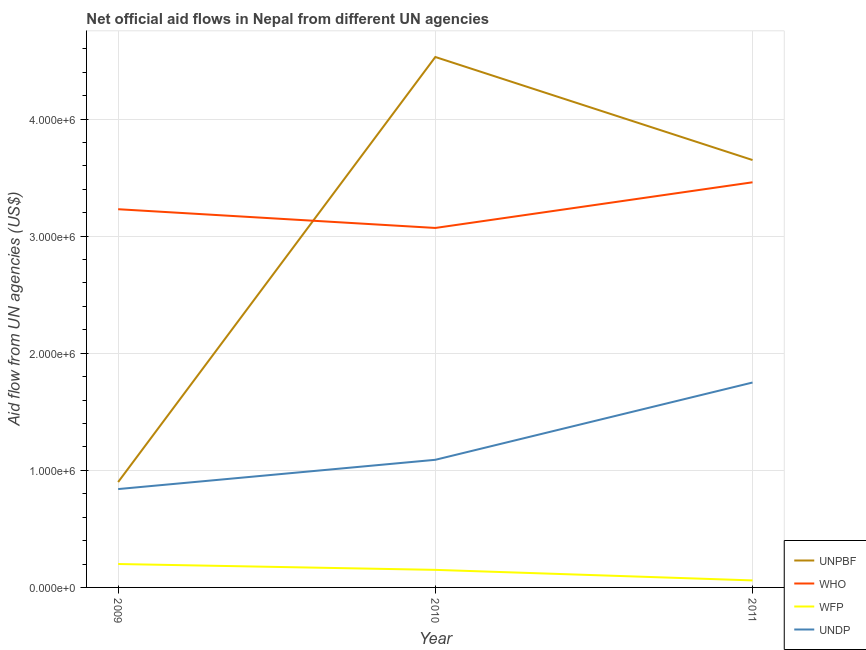How many different coloured lines are there?
Your answer should be compact. 4. What is the amount of aid given by undp in 2009?
Offer a terse response. 8.40e+05. Across all years, what is the maximum amount of aid given by undp?
Give a very brief answer. 1.75e+06. Across all years, what is the minimum amount of aid given by wfp?
Keep it short and to the point. 6.00e+04. In which year was the amount of aid given by wfp minimum?
Your answer should be very brief. 2011. What is the total amount of aid given by wfp in the graph?
Make the answer very short. 4.10e+05. What is the difference between the amount of aid given by who in 2009 and that in 2011?
Offer a very short reply. -2.30e+05. What is the difference between the amount of aid given by unpbf in 2011 and the amount of aid given by wfp in 2009?
Keep it short and to the point. 3.45e+06. What is the average amount of aid given by unpbf per year?
Give a very brief answer. 3.03e+06. In the year 2011, what is the difference between the amount of aid given by wfp and amount of aid given by unpbf?
Offer a very short reply. -3.59e+06. In how many years, is the amount of aid given by unpbf greater than 3000000 US$?
Your answer should be very brief. 2. What is the ratio of the amount of aid given by wfp in 2009 to that in 2010?
Offer a terse response. 1.33. What is the difference between the highest and the lowest amount of aid given by undp?
Keep it short and to the point. 9.10e+05. In how many years, is the amount of aid given by wfp greater than the average amount of aid given by wfp taken over all years?
Your answer should be very brief. 2. Is the sum of the amount of aid given by unpbf in 2010 and 2011 greater than the maximum amount of aid given by wfp across all years?
Provide a short and direct response. Yes. Is it the case that in every year, the sum of the amount of aid given by unpbf and amount of aid given by who is greater than the amount of aid given by wfp?
Your response must be concise. Yes. Does the amount of aid given by unpbf monotonically increase over the years?
Provide a short and direct response. No. Is the amount of aid given by who strictly greater than the amount of aid given by undp over the years?
Ensure brevity in your answer.  Yes. Is the amount of aid given by undp strictly less than the amount of aid given by wfp over the years?
Offer a terse response. No. Are the values on the major ticks of Y-axis written in scientific E-notation?
Your answer should be very brief. Yes. Does the graph contain any zero values?
Your answer should be compact. No. Where does the legend appear in the graph?
Give a very brief answer. Bottom right. How many legend labels are there?
Make the answer very short. 4. What is the title of the graph?
Provide a short and direct response. Net official aid flows in Nepal from different UN agencies. Does "Taxes on revenue" appear as one of the legend labels in the graph?
Your response must be concise. No. What is the label or title of the Y-axis?
Keep it short and to the point. Aid flow from UN agencies (US$). What is the Aid flow from UN agencies (US$) in UNPBF in 2009?
Your answer should be very brief. 9.00e+05. What is the Aid flow from UN agencies (US$) in WHO in 2009?
Your answer should be very brief. 3.23e+06. What is the Aid flow from UN agencies (US$) of WFP in 2009?
Make the answer very short. 2.00e+05. What is the Aid flow from UN agencies (US$) in UNDP in 2009?
Your response must be concise. 8.40e+05. What is the Aid flow from UN agencies (US$) of UNPBF in 2010?
Your answer should be compact. 4.53e+06. What is the Aid flow from UN agencies (US$) of WHO in 2010?
Your answer should be very brief. 3.07e+06. What is the Aid flow from UN agencies (US$) of WFP in 2010?
Give a very brief answer. 1.50e+05. What is the Aid flow from UN agencies (US$) in UNDP in 2010?
Your answer should be very brief. 1.09e+06. What is the Aid flow from UN agencies (US$) of UNPBF in 2011?
Provide a succinct answer. 3.65e+06. What is the Aid flow from UN agencies (US$) in WHO in 2011?
Give a very brief answer. 3.46e+06. What is the Aid flow from UN agencies (US$) of UNDP in 2011?
Provide a succinct answer. 1.75e+06. Across all years, what is the maximum Aid flow from UN agencies (US$) of UNPBF?
Ensure brevity in your answer.  4.53e+06. Across all years, what is the maximum Aid flow from UN agencies (US$) in WHO?
Make the answer very short. 3.46e+06. Across all years, what is the maximum Aid flow from UN agencies (US$) of WFP?
Make the answer very short. 2.00e+05. Across all years, what is the maximum Aid flow from UN agencies (US$) of UNDP?
Keep it short and to the point. 1.75e+06. Across all years, what is the minimum Aid flow from UN agencies (US$) of WHO?
Your answer should be very brief. 3.07e+06. Across all years, what is the minimum Aid flow from UN agencies (US$) of WFP?
Your answer should be very brief. 6.00e+04. Across all years, what is the minimum Aid flow from UN agencies (US$) in UNDP?
Keep it short and to the point. 8.40e+05. What is the total Aid flow from UN agencies (US$) of UNPBF in the graph?
Keep it short and to the point. 9.08e+06. What is the total Aid flow from UN agencies (US$) in WHO in the graph?
Provide a succinct answer. 9.76e+06. What is the total Aid flow from UN agencies (US$) of UNDP in the graph?
Your answer should be very brief. 3.68e+06. What is the difference between the Aid flow from UN agencies (US$) of UNPBF in 2009 and that in 2010?
Give a very brief answer. -3.63e+06. What is the difference between the Aid flow from UN agencies (US$) in WHO in 2009 and that in 2010?
Your response must be concise. 1.60e+05. What is the difference between the Aid flow from UN agencies (US$) in WFP in 2009 and that in 2010?
Your answer should be very brief. 5.00e+04. What is the difference between the Aid flow from UN agencies (US$) of UNPBF in 2009 and that in 2011?
Give a very brief answer. -2.75e+06. What is the difference between the Aid flow from UN agencies (US$) of WHO in 2009 and that in 2011?
Ensure brevity in your answer.  -2.30e+05. What is the difference between the Aid flow from UN agencies (US$) of UNDP in 2009 and that in 2011?
Your answer should be very brief. -9.10e+05. What is the difference between the Aid flow from UN agencies (US$) in UNPBF in 2010 and that in 2011?
Your answer should be compact. 8.80e+05. What is the difference between the Aid flow from UN agencies (US$) of WHO in 2010 and that in 2011?
Provide a short and direct response. -3.90e+05. What is the difference between the Aid flow from UN agencies (US$) of WFP in 2010 and that in 2011?
Your response must be concise. 9.00e+04. What is the difference between the Aid flow from UN agencies (US$) in UNDP in 2010 and that in 2011?
Give a very brief answer. -6.60e+05. What is the difference between the Aid flow from UN agencies (US$) of UNPBF in 2009 and the Aid flow from UN agencies (US$) of WHO in 2010?
Give a very brief answer. -2.17e+06. What is the difference between the Aid flow from UN agencies (US$) of UNPBF in 2009 and the Aid flow from UN agencies (US$) of WFP in 2010?
Give a very brief answer. 7.50e+05. What is the difference between the Aid flow from UN agencies (US$) in WHO in 2009 and the Aid flow from UN agencies (US$) in WFP in 2010?
Make the answer very short. 3.08e+06. What is the difference between the Aid flow from UN agencies (US$) of WHO in 2009 and the Aid flow from UN agencies (US$) of UNDP in 2010?
Give a very brief answer. 2.14e+06. What is the difference between the Aid flow from UN agencies (US$) in WFP in 2009 and the Aid flow from UN agencies (US$) in UNDP in 2010?
Give a very brief answer. -8.90e+05. What is the difference between the Aid flow from UN agencies (US$) of UNPBF in 2009 and the Aid flow from UN agencies (US$) of WHO in 2011?
Give a very brief answer. -2.56e+06. What is the difference between the Aid flow from UN agencies (US$) in UNPBF in 2009 and the Aid flow from UN agencies (US$) in WFP in 2011?
Give a very brief answer. 8.40e+05. What is the difference between the Aid flow from UN agencies (US$) in UNPBF in 2009 and the Aid flow from UN agencies (US$) in UNDP in 2011?
Your answer should be compact. -8.50e+05. What is the difference between the Aid flow from UN agencies (US$) in WHO in 2009 and the Aid flow from UN agencies (US$) in WFP in 2011?
Provide a succinct answer. 3.17e+06. What is the difference between the Aid flow from UN agencies (US$) in WHO in 2009 and the Aid flow from UN agencies (US$) in UNDP in 2011?
Ensure brevity in your answer.  1.48e+06. What is the difference between the Aid flow from UN agencies (US$) of WFP in 2009 and the Aid flow from UN agencies (US$) of UNDP in 2011?
Provide a succinct answer. -1.55e+06. What is the difference between the Aid flow from UN agencies (US$) in UNPBF in 2010 and the Aid flow from UN agencies (US$) in WHO in 2011?
Make the answer very short. 1.07e+06. What is the difference between the Aid flow from UN agencies (US$) in UNPBF in 2010 and the Aid flow from UN agencies (US$) in WFP in 2011?
Your response must be concise. 4.47e+06. What is the difference between the Aid flow from UN agencies (US$) in UNPBF in 2010 and the Aid flow from UN agencies (US$) in UNDP in 2011?
Make the answer very short. 2.78e+06. What is the difference between the Aid flow from UN agencies (US$) of WHO in 2010 and the Aid flow from UN agencies (US$) of WFP in 2011?
Your answer should be very brief. 3.01e+06. What is the difference between the Aid flow from UN agencies (US$) of WHO in 2010 and the Aid flow from UN agencies (US$) of UNDP in 2011?
Your response must be concise. 1.32e+06. What is the difference between the Aid flow from UN agencies (US$) of WFP in 2010 and the Aid flow from UN agencies (US$) of UNDP in 2011?
Provide a succinct answer. -1.60e+06. What is the average Aid flow from UN agencies (US$) of UNPBF per year?
Your answer should be compact. 3.03e+06. What is the average Aid flow from UN agencies (US$) in WHO per year?
Give a very brief answer. 3.25e+06. What is the average Aid flow from UN agencies (US$) in WFP per year?
Offer a very short reply. 1.37e+05. What is the average Aid flow from UN agencies (US$) of UNDP per year?
Make the answer very short. 1.23e+06. In the year 2009, what is the difference between the Aid flow from UN agencies (US$) in UNPBF and Aid flow from UN agencies (US$) in WHO?
Your answer should be compact. -2.33e+06. In the year 2009, what is the difference between the Aid flow from UN agencies (US$) in UNPBF and Aid flow from UN agencies (US$) in WFP?
Give a very brief answer. 7.00e+05. In the year 2009, what is the difference between the Aid flow from UN agencies (US$) in UNPBF and Aid flow from UN agencies (US$) in UNDP?
Ensure brevity in your answer.  6.00e+04. In the year 2009, what is the difference between the Aid flow from UN agencies (US$) of WHO and Aid flow from UN agencies (US$) of WFP?
Provide a succinct answer. 3.03e+06. In the year 2009, what is the difference between the Aid flow from UN agencies (US$) of WHO and Aid flow from UN agencies (US$) of UNDP?
Offer a terse response. 2.39e+06. In the year 2009, what is the difference between the Aid flow from UN agencies (US$) of WFP and Aid flow from UN agencies (US$) of UNDP?
Your answer should be compact. -6.40e+05. In the year 2010, what is the difference between the Aid flow from UN agencies (US$) of UNPBF and Aid flow from UN agencies (US$) of WHO?
Your answer should be compact. 1.46e+06. In the year 2010, what is the difference between the Aid flow from UN agencies (US$) of UNPBF and Aid flow from UN agencies (US$) of WFP?
Give a very brief answer. 4.38e+06. In the year 2010, what is the difference between the Aid flow from UN agencies (US$) in UNPBF and Aid flow from UN agencies (US$) in UNDP?
Make the answer very short. 3.44e+06. In the year 2010, what is the difference between the Aid flow from UN agencies (US$) of WHO and Aid flow from UN agencies (US$) of WFP?
Offer a terse response. 2.92e+06. In the year 2010, what is the difference between the Aid flow from UN agencies (US$) of WHO and Aid flow from UN agencies (US$) of UNDP?
Your response must be concise. 1.98e+06. In the year 2010, what is the difference between the Aid flow from UN agencies (US$) of WFP and Aid flow from UN agencies (US$) of UNDP?
Provide a short and direct response. -9.40e+05. In the year 2011, what is the difference between the Aid flow from UN agencies (US$) of UNPBF and Aid flow from UN agencies (US$) of WFP?
Your answer should be compact. 3.59e+06. In the year 2011, what is the difference between the Aid flow from UN agencies (US$) in UNPBF and Aid flow from UN agencies (US$) in UNDP?
Make the answer very short. 1.90e+06. In the year 2011, what is the difference between the Aid flow from UN agencies (US$) in WHO and Aid flow from UN agencies (US$) in WFP?
Your answer should be compact. 3.40e+06. In the year 2011, what is the difference between the Aid flow from UN agencies (US$) in WHO and Aid flow from UN agencies (US$) in UNDP?
Make the answer very short. 1.71e+06. In the year 2011, what is the difference between the Aid flow from UN agencies (US$) of WFP and Aid flow from UN agencies (US$) of UNDP?
Ensure brevity in your answer.  -1.69e+06. What is the ratio of the Aid flow from UN agencies (US$) of UNPBF in 2009 to that in 2010?
Your answer should be compact. 0.2. What is the ratio of the Aid flow from UN agencies (US$) in WHO in 2009 to that in 2010?
Make the answer very short. 1.05. What is the ratio of the Aid flow from UN agencies (US$) in UNDP in 2009 to that in 2010?
Your response must be concise. 0.77. What is the ratio of the Aid flow from UN agencies (US$) of UNPBF in 2009 to that in 2011?
Your answer should be compact. 0.25. What is the ratio of the Aid flow from UN agencies (US$) in WHO in 2009 to that in 2011?
Give a very brief answer. 0.93. What is the ratio of the Aid flow from UN agencies (US$) of WFP in 2009 to that in 2011?
Your answer should be very brief. 3.33. What is the ratio of the Aid flow from UN agencies (US$) in UNDP in 2009 to that in 2011?
Offer a terse response. 0.48. What is the ratio of the Aid flow from UN agencies (US$) of UNPBF in 2010 to that in 2011?
Make the answer very short. 1.24. What is the ratio of the Aid flow from UN agencies (US$) of WHO in 2010 to that in 2011?
Offer a terse response. 0.89. What is the ratio of the Aid flow from UN agencies (US$) in UNDP in 2010 to that in 2011?
Provide a succinct answer. 0.62. What is the difference between the highest and the second highest Aid flow from UN agencies (US$) in UNPBF?
Keep it short and to the point. 8.80e+05. What is the difference between the highest and the second highest Aid flow from UN agencies (US$) of UNDP?
Ensure brevity in your answer.  6.60e+05. What is the difference between the highest and the lowest Aid flow from UN agencies (US$) of UNPBF?
Provide a short and direct response. 3.63e+06. What is the difference between the highest and the lowest Aid flow from UN agencies (US$) of UNDP?
Give a very brief answer. 9.10e+05. 